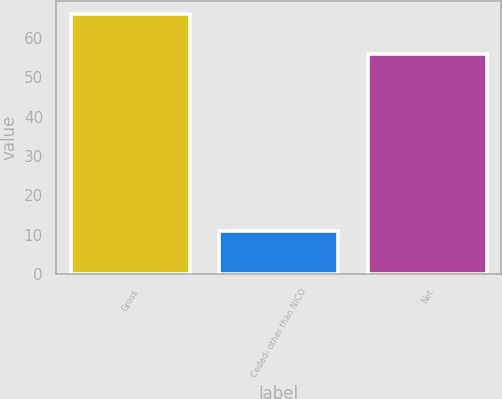Convert chart. <chart><loc_0><loc_0><loc_500><loc_500><bar_chart><fcel>Gross<fcel>Ceded- other than NICO<fcel>Net<nl><fcel>66<fcel>11<fcel>56<nl></chart> 